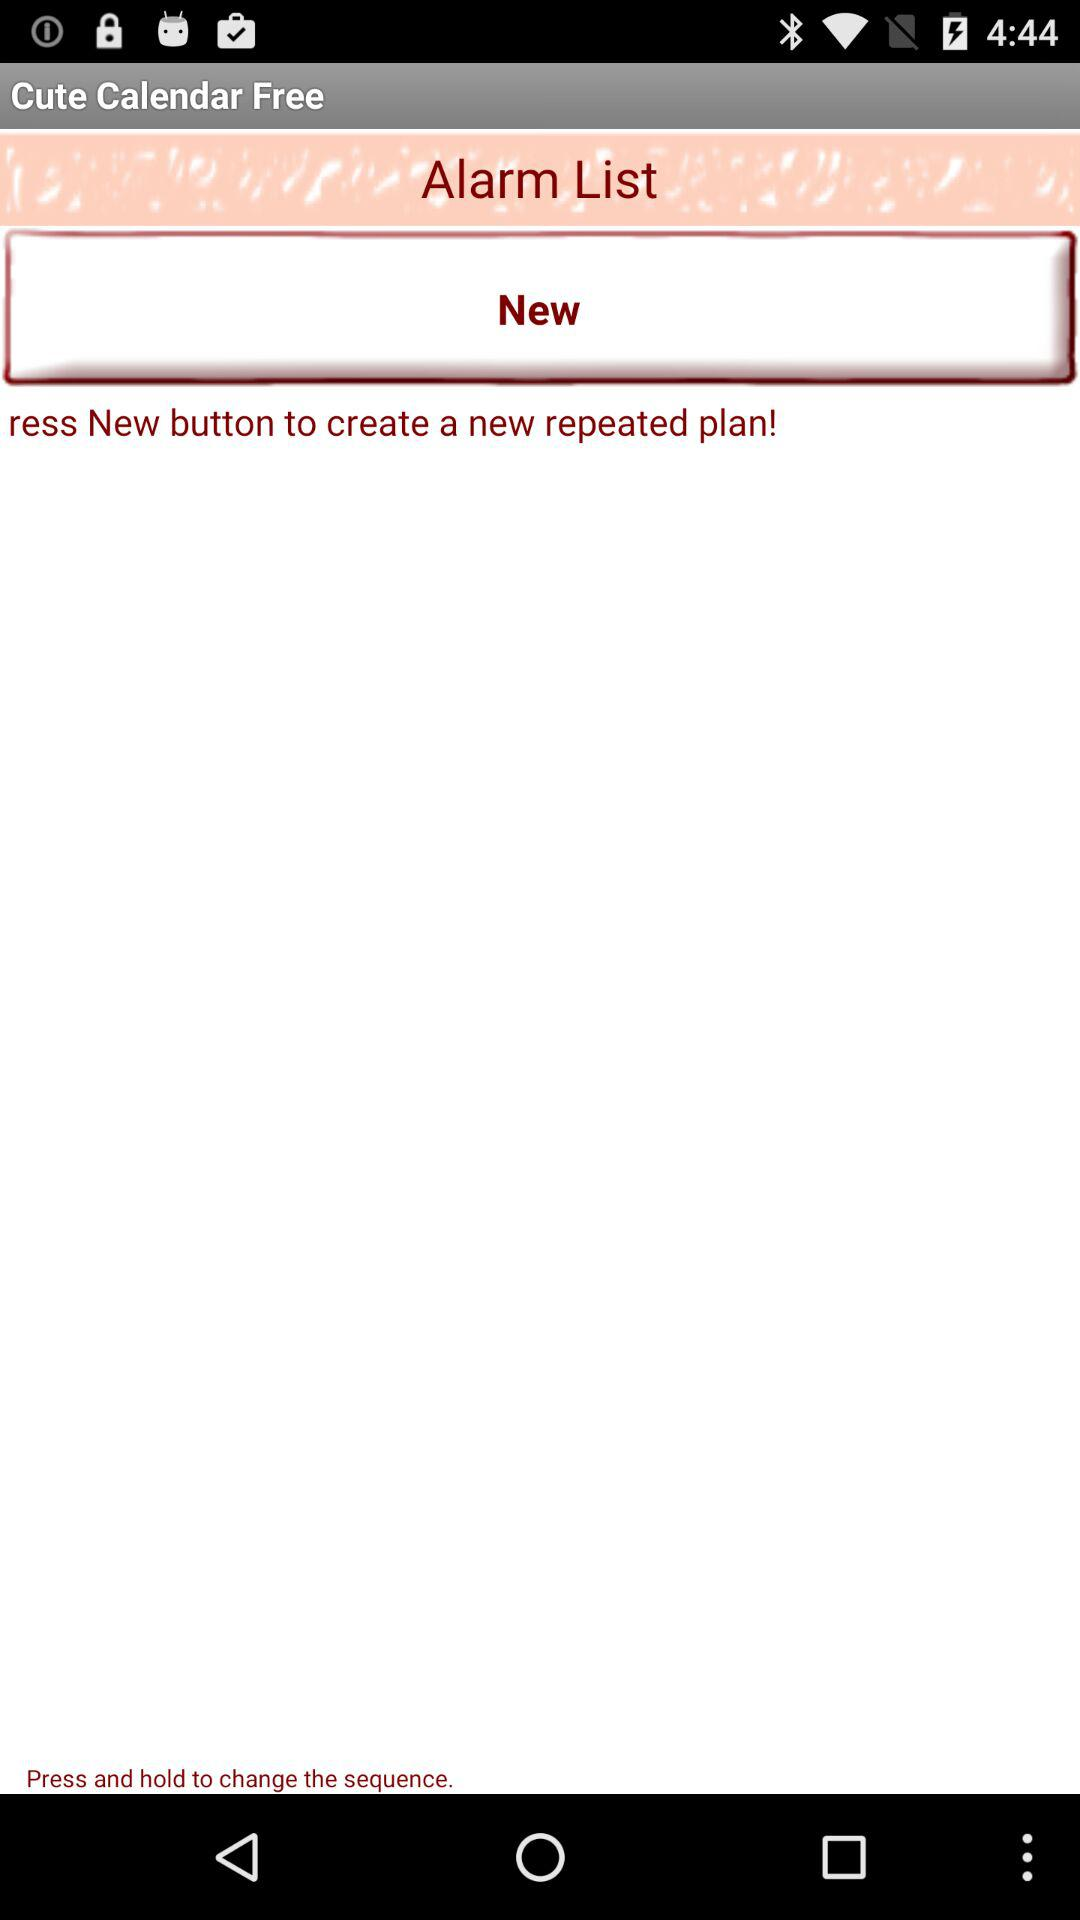What is the name of the application? The application name is "Cute Calendar". 